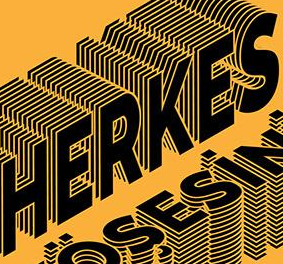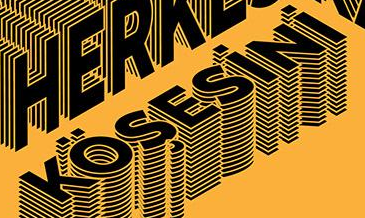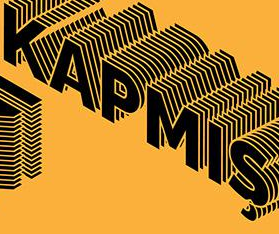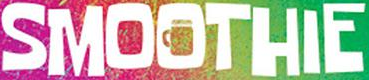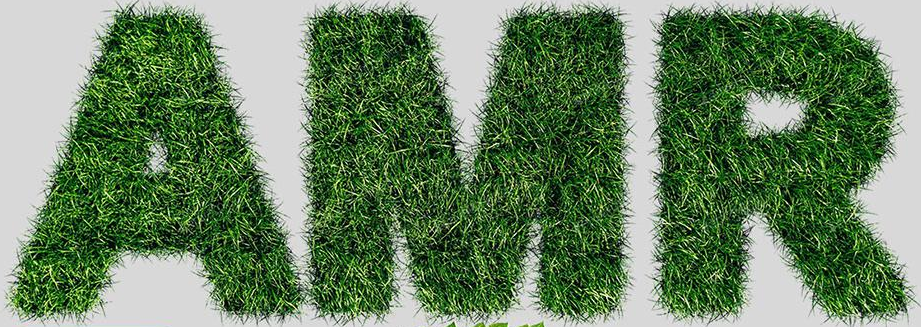What words can you see in these images in sequence, separated by a semicolon? HERKES; KÖŞESiNi; KAPMIŞ; SMOOTHIE; AMR 